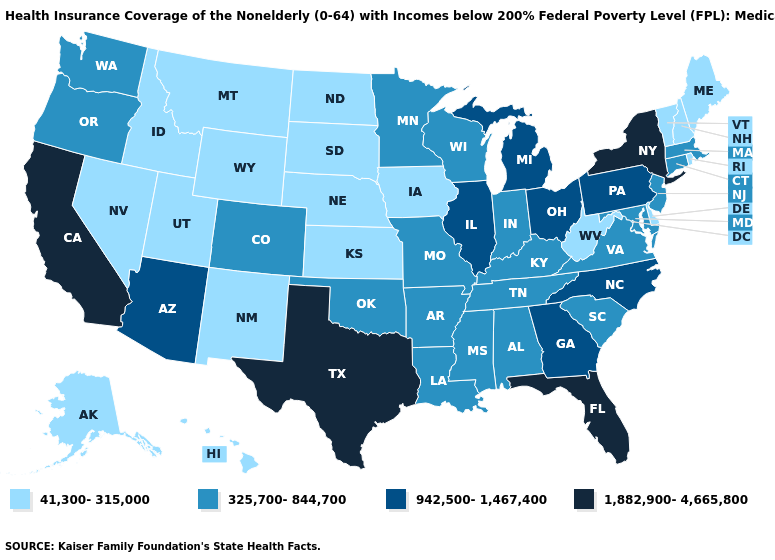Name the states that have a value in the range 1,882,900-4,665,800?
Keep it brief. California, Florida, New York, Texas. Is the legend a continuous bar?
Be succinct. No. Name the states that have a value in the range 41,300-315,000?
Write a very short answer. Alaska, Delaware, Hawaii, Idaho, Iowa, Kansas, Maine, Montana, Nebraska, Nevada, New Hampshire, New Mexico, North Dakota, Rhode Island, South Dakota, Utah, Vermont, West Virginia, Wyoming. Among the states that border Arkansas , does Louisiana have the lowest value?
Answer briefly. Yes. What is the value of Pennsylvania?
Write a very short answer. 942,500-1,467,400. What is the lowest value in states that border Georgia?
Short answer required. 325,700-844,700. Name the states that have a value in the range 325,700-844,700?
Quick response, please. Alabama, Arkansas, Colorado, Connecticut, Indiana, Kentucky, Louisiana, Maryland, Massachusetts, Minnesota, Mississippi, Missouri, New Jersey, Oklahoma, Oregon, South Carolina, Tennessee, Virginia, Washington, Wisconsin. What is the value of Kentucky?
Be succinct. 325,700-844,700. What is the value of Arkansas?
Short answer required. 325,700-844,700. Does New Hampshire have a lower value than Missouri?
Concise answer only. Yes. What is the value of Kentucky?
Answer briefly. 325,700-844,700. What is the highest value in states that border Alabama?
Give a very brief answer. 1,882,900-4,665,800. Does the first symbol in the legend represent the smallest category?
Quick response, please. Yes. What is the highest value in the MidWest ?
Short answer required. 942,500-1,467,400. What is the value of New York?
Be succinct. 1,882,900-4,665,800. 